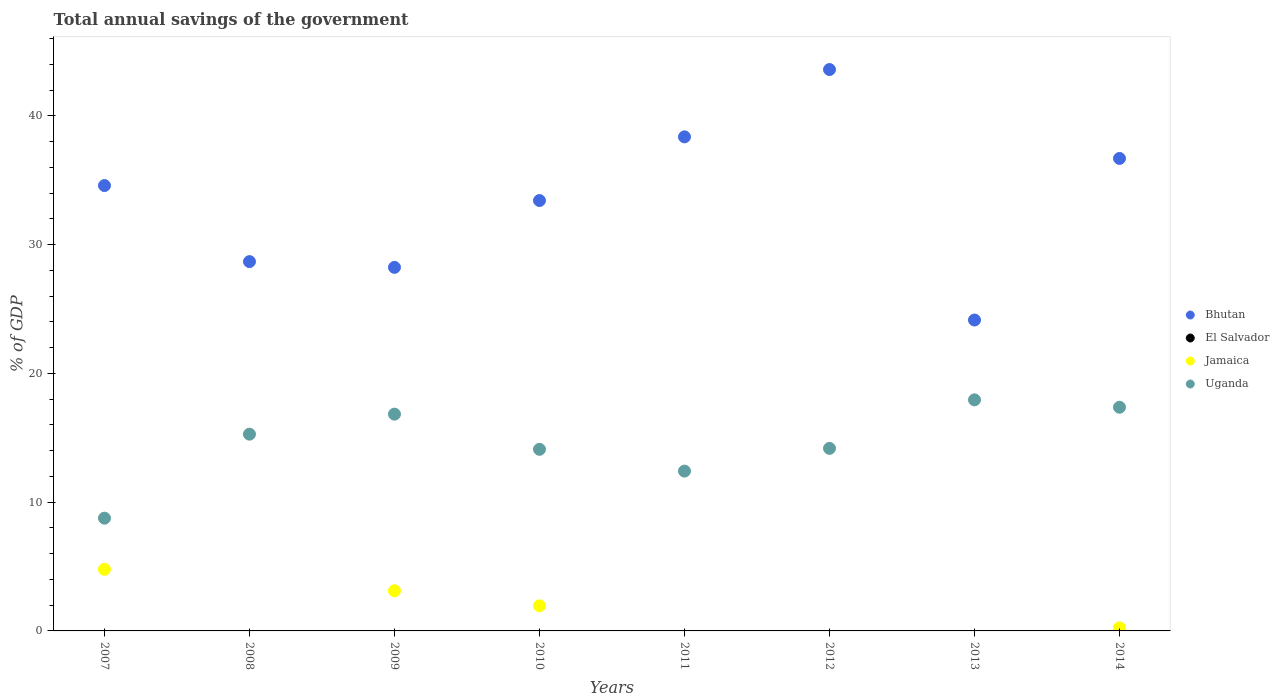How many different coloured dotlines are there?
Keep it short and to the point. 3. Is the number of dotlines equal to the number of legend labels?
Keep it short and to the point. No. What is the total annual savings of the government in Bhutan in 2013?
Provide a succinct answer. 24.15. Across all years, what is the maximum total annual savings of the government in Bhutan?
Offer a very short reply. 43.6. Across all years, what is the minimum total annual savings of the government in Uganda?
Give a very brief answer. 8.76. In which year was the total annual savings of the government in Jamaica maximum?
Provide a short and direct response. 2007. What is the total total annual savings of the government in Bhutan in the graph?
Your answer should be compact. 267.74. What is the difference between the total annual savings of the government in Jamaica in 2007 and that in 2010?
Your answer should be very brief. 2.84. What is the difference between the total annual savings of the government in Bhutan in 2012 and the total annual savings of the government in El Salvador in 2009?
Provide a succinct answer. 43.6. What is the average total annual savings of the government in El Salvador per year?
Provide a short and direct response. 0. In the year 2009, what is the difference between the total annual savings of the government in Bhutan and total annual savings of the government in Uganda?
Keep it short and to the point. 11.4. In how many years, is the total annual savings of the government in Bhutan greater than 34 %?
Your answer should be very brief. 4. What is the ratio of the total annual savings of the government in Uganda in 2009 to that in 2010?
Offer a terse response. 1.19. Is the total annual savings of the government in Bhutan in 2007 less than that in 2008?
Provide a short and direct response. No. What is the difference between the highest and the second highest total annual savings of the government in Uganda?
Provide a succinct answer. 0.58. What is the difference between the highest and the lowest total annual savings of the government in Bhutan?
Offer a terse response. 19.45. In how many years, is the total annual savings of the government in Uganda greater than the average total annual savings of the government in Uganda taken over all years?
Give a very brief answer. 4. Is the sum of the total annual savings of the government in Uganda in 2012 and 2013 greater than the maximum total annual savings of the government in Jamaica across all years?
Provide a succinct answer. Yes. Is it the case that in every year, the sum of the total annual savings of the government in Bhutan and total annual savings of the government in El Salvador  is greater than the sum of total annual savings of the government in Uganda and total annual savings of the government in Jamaica?
Make the answer very short. Yes. Does the total annual savings of the government in Jamaica monotonically increase over the years?
Give a very brief answer. No. Is the total annual savings of the government in Uganda strictly greater than the total annual savings of the government in Bhutan over the years?
Your answer should be very brief. No. Is the total annual savings of the government in Uganda strictly less than the total annual savings of the government in El Salvador over the years?
Keep it short and to the point. No. Are the values on the major ticks of Y-axis written in scientific E-notation?
Your answer should be very brief. No. Does the graph contain any zero values?
Your answer should be very brief. Yes. How many legend labels are there?
Keep it short and to the point. 4. How are the legend labels stacked?
Offer a very short reply. Vertical. What is the title of the graph?
Your response must be concise. Total annual savings of the government. What is the label or title of the Y-axis?
Give a very brief answer. % of GDP. What is the % of GDP in Bhutan in 2007?
Offer a very short reply. 34.59. What is the % of GDP of Jamaica in 2007?
Ensure brevity in your answer.  4.78. What is the % of GDP of Uganda in 2007?
Offer a terse response. 8.76. What is the % of GDP of Bhutan in 2008?
Make the answer very short. 28.68. What is the % of GDP in Jamaica in 2008?
Provide a short and direct response. 0. What is the % of GDP of Uganda in 2008?
Provide a short and direct response. 15.28. What is the % of GDP in Bhutan in 2009?
Make the answer very short. 28.23. What is the % of GDP in El Salvador in 2009?
Your answer should be compact. 0. What is the % of GDP of Jamaica in 2009?
Keep it short and to the point. 3.12. What is the % of GDP in Uganda in 2009?
Give a very brief answer. 16.84. What is the % of GDP in Bhutan in 2010?
Give a very brief answer. 33.42. What is the % of GDP of Jamaica in 2010?
Your answer should be compact. 1.95. What is the % of GDP in Uganda in 2010?
Your answer should be very brief. 14.1. What is the % of GDP in Bhutan in 2011?
Offer a very short reply. 38.37. What is the % of GDP of El Salvador in 2011?
Provide a succinct answer. 0. What is the % of GDP of Uganda in 2011?
Keep it short and to the point. 12.41. What is the % of GDP of Bhutan in 2012?
Offer a terse response. 43.6. What is the % of GDP in El Salvador in 2012?
Offer a terse response. 0. What is the % of GDP in Jamaica in 2012?
Make the answer very short. 0. What is the % of GDP in Uganda in 2012?
Give a very brief answer. 14.18. What is the % of GDP in Bhutan in 2013?
Offer a very short reply. 24.15. What is the % of GDP of El Salvador in 2013?
Provide a succinct answer. 0. What is the % of GDP of Jamaica in 2013?
Ensure brevity in your answer.  0. What is the % of GDP of Uganda in 2013?
Provide a succinct answer. 17.95. What is the % of GDP of Bhutan in 2014?
Offer a very short reply. 36.69. What is the % of GDP of El Salvador in 2014?
Your answer should be very brief. 0. What is the % of GDP of Jamaica in 2014?
Keep it short and to the point. 0.24. What is the % of GDP of Uganda in 2014?
Offer a very short reply. 17.37. Across all years, what is the maximum % of GDP of Bhutan?
Ensure brevity in your answer.  43.6. Across all years, what is the maximum % of GDP in Jamaica?
Ensure brevity in your answer.  4.78. Across all years, what is the maximum % of GDP of Uganda?
Your answer should be compact. 17.95. Across all years, what is the minimum % of GDP in Bhutan?
Your answer should be compact. 24.15. Across all years, what is the minimum % of GDP in Uganda?
Your answer should be compact. 8.76. What is the total % of GDP of Bhutan in the graph?
Provide a succinct answer. 267.74. What is the total % of GDP in El Salvador in the graph?
Ensure brevity in your answer.  0. What is the total % of GDP of Jamaica in the graph?
Keep it short and to the point. 10.09. What is the total % of GDP of Uganda in the graph?
Ensure brevity in your answer.  116.88. What is the difference between the % of GDP of Bhutan in 2007 and that in 2008?
Offer a terse response. 5.91. What is the difference between the % of GDP of Uganda in 2007 and that in 2008?
Give a very brief answer. -6.52. What is the difference between the % of GDP of Bhutan in 2007 and that in 2009?
Ensure brevity in your answer.  6.35. What is the difference between the % of GDP of Jamaica in 2007 and that in 2009?
Provide a succinct answer. 1.66. What is the difference between the % of GDP of Uganda in 2007 and that in 2009?
Your response must be concise. -8.08. What is the difference between the % of GDP of Bhutan in 2007 and that in 2010?
Keep it short and to the point. 1.16. What is the difference between the % of GDP of Jamaica in 2007 and that in 2010?
Your answer should be compact. 2.84. What is the difference between the % of GDP in Uganda in 2007 and that in 2010?
Offer a terse response. -5.35. What is the difference between the % of GDP of Bhutan in 2007 and that in 2011?
Offer a very short reply. -3.78. What is the difference between the % of GDP of Uganda in 2007 and that in 2011?
Keep it short and to the point. -3.66. What is the difference between the % of GDP of Bhutan in 2007 and that in 2012?
Provide a succinct answer. -9.01. What is the difference between the % of GDP in Uganda in 2007 and that in 2012?
Provide a short and direct response. -5.42. What is the difference between the % of GDP in Bhutan in 2007 and that in 2013?
Keep it short and to the point. 10.44. What is the difference between the % of GDP of Uganda in 2007 and that in 2013?
Offer a terse response. -9.19. What is the difference between the % of GDP in Bhutan in 2007 and that in 2014?
Your answer should be very brief. -2.11. What is the difference between the % of GDP of Jamaica in 2007 and that in 2014?
Make the answer very short. 4.55. What is the difference between the % of GDP in Uganda in 2007 and that in 2014?
Keep it short and to the point. -8.61. What is the difference between the % of GDP in Bhutan in 2008 and that in 2009?
Your answer should be compact. 0.45. What is the difference between the % of GDP in Uganda in 2008 and that in 2009?
Ensure brevity in your answer.  -1.56. What is the difference between the % of GDP of Bhutan in 2008 and that in 2010?
Make the answer very short. -4.74. What is the difference between the % of GDP in Uganda in 2008 and that in 2010?
Offer a terse response. 1.18. What is the difference between the % of GDP in Bhutan in 2008 and that in 2011?
Ensure brevity in your answer.  -9.69. What is the difference between the % of GDP of Uganda in 2008 and that in 2011?
Keep it short and to the point. 2.87. What is the difference between the % of GDP in Bhutan in 2008 and that in 2012?
Offer a terse response. -14.92. What is the difference between the % of GDP of Uganda in 2008 and that in 2012?
Your answer should be very brief. 1.1. What is the difference between the % of GDP in Bhutan in 2008 and that in 2013?
Give a very brief answer. 4.54. What is the difference between the % of GDP of Uganda in 2008 and that in 2013?
Ensure brevity in your answer.  -2.67. What is the difference between the % of GDP of Bhutan in 2008 and that in 2014?
Provide a succinct answer. -8.01. What is the difference between the % of GDP of Uganda in 2008 and that in 2014?
Your response must be concise. -2.09. What is the difference between the % of GDP of Bhutan in 2009 and that in 2010?
Offer a very short reply. -5.19. What is the difference between the % of GDP of Jamaica in 2009 and that in 2010?
Offer a very short reply. 1.17. What is the difference between the % of GDP in Uganda in 2009 and that in 2010?
Keep it short and to the point. 2.73. What is the difference between the % of GDP in Bhutan in 2009 and that in 2011?
Provide a succinct answer. -10.14. What is the difference between the % of GDP of Uganda in 2009 and that in 2011?
Offer a very short reply. 4.42. What is the difference between the % of GDP in Bhutan in 2009 and that in 2012?
Offer a terse response. -15.36. What is the difference between the % of GDP in Uganda in 2009 and that in 2012?
Your answer should be very brief. 2.66. What is the difference between the % of GDP in Bhutan in 2009 and that in 2013?
Your response must be concise. 4.09. What is the difference between the % of GDP of Uganda in 2009 and that in 2013?
Offer a terse response. -1.11. What is the difference between the % of GDP in Bhutan in 2009 and that in 2014?
Your answer should be compact. -8.46. What is the difference between the % of GDP of Jamaica in 2009 and that in 2014?
Provide a succinct answer. 2.88. What is the difference between the % of GDP in Uganda in 2009 and that in 2014?
Ensure brevity in your answer.  -0.53. What is the difference between the % of GDP in Bhutan in 2010 and that in 2011?
Provide a succinct answer. -4.95. What is the difference between the % of GDP of Uganda in 2010 and that in 2011?
Provide a succinct answer. 1.69. What is the difference between the % of GDP in Bhutan in 2010 and that in 2012?
Make the answer very short. -10.17. What is the difference between the % of GDP of Uganda in 2010 and that in 2012?
Provide a short and direct response. -0.07. What is the difference between the % of GDP in Bhutan in 2010 and that in 2013?
Your answer should be compact. 9.28. What is the difference between the % of GDP of Uganda in 2010 and that in 2013?
Provide a short and direct response. -3.84. What is the difference between the % of GDP of Bhutan in 2010 and that in 2014?
Offer a terse response. -3.27. What is the difference between the % of GDP of Jamaica in 2010 and that in 2014?
Keep it short and to the point. 1.71. What is the difference between the % of GDP in Uganda in 2010 and that in 2014?
Offer a terse response. -3.27. What is the difference between the % of GDP in Bhutan in 2011 and that in 2012?
Offer a terse response. -5.23. What is the difference between the % of GDP of Uganda in 2011 and that in 2012?
Offer a terse response. -1.76. What is the difference between the % of GDP of Bhutan in 2011 and that in 2013?
Give a very brief answer. 14.22. What is the difference between the % of GDP of Uganda in 2011 and that in 2013?
Your response must be concise. -5.53. What is the difference between the % of GDP in Bhutan in 2011 and that in 2014?
Ensure brevity in your answer.  1.68. What is the difference between the % of GDP of Uganda in 2011 and that in 2014?
Offer a very short reply. -4.96. What is the difference between the % of GDP of Bhutan in 2012 and that in 2013?
Provide a succinct answer. 19.45. What is the difference between the % of GDP in Uganda in 2012 and that in 2013?
Provide a short and direct response. -3.77. What is the difference between the % of GDP in Bhutan in 2012 and that in 2014?
Offer a very short reply. 6.9. What is the difference between the % of GDP in Uganda in 2012 and that in 2014?
Provide a succinct answer. -3.19. What is the difference between the % of GDP of Bhutan in 2013 and that in 2014?
Provide a short and direct response. -12.55. What is the difference between the % of GDP in Uganda in 2013 and that in 2014?
Give a very brief answer. 0.58. What is the difference between the % of GDP of Bhutan in 2007 and the % of GDP of Uganda in 2008?
Your response must be concise. 19.31. What is the difference between the % of GDP in Jamaica in 2007 and the % of GDP in Uganda in 2008?
Offer a terse response. -10.5. What is the difference between the % of GDP of Bhutan in 2007 and the % of GDP of Jamaica in 2009?
Ensure brevity in your answer.  31.47. What is the difference between the % of GDP of Bhutan in 2007 and the % of GDP of Uganda in 2009?
Keep it short and to the point. 17.75. What is the difference between the % of GDP in Jamaica in 2007 and the % of GDP in Uganda in 2009?
Your answer should be compact. -12.05. What is the difference between the % of GDP in Bhutan in 2007 and the % of GDP in Jamaica in 2010?
Keep it short and to the point. 32.64. What is the difference between the % of GDP in Bhutan in 2007 and the % of GDP in Uganda in 2010?
Give a very brief answer. 20.49. What is the difference between the % of GDP of Jamaica in 2007 and the % of GDP of Uganda in 2010?
Ensure brevity in your answer.  -9.32. What is the difference between the % of GDP in Bhutan in 2007 and the % of GDP in Uganda in 2011?
Your answer should be compact. 22.18. What is the difference between the % of GDP of Jamaica in 2007 and the % of GDP of Uganda in 2011?
Offer a terse response. -7.63. What is the difference between the % of GDP in Bhutan in 2007 and the % of GDP in Uganda in 2012?
Offer a terse response. 20.41. What is the difference between the % of GDP of Jamaica in 2007 and the % of GDP of Uganda in 2012?
Your answer should be compact. -9.39. What is the difference between the % of GDP of Bhutan in 2007 and the % of GDP of Uganda in 2013?
Keep it short and to the point. 16.64. What is the difference between the % of GDP in Jamaica in 2007 and the % of GDP in Uganda in 2013?
Your answer should be very brief. -13.16. What is the difference between the % of GDP of Bhutan in 2007 and the % of GDP of Jamaica in 2014?
Your answer should be very brief. 34.35. What is the difference between the % of GDP in Bhutan in 2007 and the % of GDP in Uganda in 2014?
Give a very brief answer. 17.22. What is the difference between the % of GDP of Jamaica in 2007 and the % of GDP of Uganda in 2014?
Provide a succinct answer. -12.59. What is the difference between the % of GDP of Bhutan in 2008 and the % of GDP of Jamaica in 2009?
Offer a very short reply. 25.56. What is the difference between the % of GDP of Bhutan in 2008 and the % of GDP of Uganda in 2009?
Ensure brevity in your answer.  11.85. What is the difference between the % of GDP of Bhutan in 2008 and the % of GDP of Jamaica in 2010?
Your response must be concise. 26.73. What is the difference between the % of GDP in Bhutan in 2008 and the % of GDP in Uganda in 2010?
Give a very brief answer. 14.58. What is the difference between the % of GDP of Bhutan in 2008 and the % of GDP of Uganda in 2011?
Your response must be concise. 16.27. What is the difference between the % of GDP of Bhutan in 2008 and the % of GDP of Uganda in 2012?
Provide a short and direct response. 14.5. What is the difference between the % of GDP of Bhutan in 2008 and the % of GDP of Uganda in 2013?
Keep it short and to the point. 10.74. What is the difference between the % of GDP in Bhutan in 2008 and the % of GDP in Jamaica in 2014?
Keep it short and to the point. 28.44. What is the difference between the % of GDP of Bhutan in 2008 and the % of GDP of Uganda in 2014?
Offer a terse response. 11.31. What is the difference between the % of GDP in Bhutan in 2009 and the % of GDP in Jamaica in 2010?
Give a very brief answer. 26.29. What is the difference between the % of GDP of Bhutan in 2009 and the % of GDP of Uganda in 2010?
Give a very brief answer. 14.13. What is the difference between the % of GDP of Jamaica in 2009 and the % of GDP of Uganda in 2010?
Your response must be concise. -10.98. What is the difference between the % of GDP in Bhutan in 2009 and the % of GDP in Uganda in 2011?
Your response must be concise. 15.82. What is the difference between the % of GDP of Jamaica in 2009 and the % of GDP of Uganda in 2011?
Your answer should be very brief. -9.29. What is the difference between the % of GDP in Bhutan in 2009 and the % of GDP in Uganda in 2012?
Give a very brief answer. 14.06. What is the difference between the % of GDP in Jamaica in 2009 and the % of GDP in Uganda in 2012?
Your answer should be very brief. -11.06. What is the difference between the % of GDP of Bhutan in 2009 and the % of GDP of Uganda in 2013?
Provide a succinct answer. 10.29. What is the difference between the % of GDP in Jamaica in 2009 and the % of GDP in Uganda in 2013?
Your answer should be very brief. -14.83. What is the difference between the % of GDP in Bhutan in 2009 and the % of GDP in Jamaica in 2014?
Your answer should be very brief. 28. What is the difference between the % of GDP of Bhutan in 2009 and the % of GDP of Uganda in 2014?
Ensure brevity in your answer.  10.86. What is the difference between the % of GDP of Jamaica in 2009 and the % of GDP of Uganda in 2014?
Give a very brief answer. -14.25. What is the difference between the % of GDP of Bhutan in 2010 and the % of GDP of Uganda in 2011?
Your answer should be compact. 21.01. What is the difference between the % of GDP in Jamaica in 2010 and the % of GDP in Uganda in 2011?
Your answer should be very brief. -10.46. What is the difference between the % of GDP of Bhutan in 2010 and the % of GDP of Uganda in 2012?
Keep it short and to the point. 19.25. What is the difference between the % of GDP in Jamaica in 2010 and the % of GDP in Uganda in 2012?
Your response must be concise. -12.23. What is the difference between the % of GDP of Bhutan in 2010 and the % of GDP of Uganda in 2013?
Provide a short and direct response. 15.48. What is the difference between the % of GDP of Jamaica in 2010 and the % of GDP of Uganda in 2013?
Ensure brevity in your answer.  -16. What is the difference between the % of GDP in Bhutan in 2010 and the % of GDP in Jamaica in 2014?
Ensure brevity in your answer.  33.18. What is the difference between the % of GDP of Bhutan in 2010 and the % of GDP of Uganda in 2014?
Your answer should be very brief. 16.05. What is the difference between the % of GDP in Jamaica in 2010 and the % of GDP in Uganda in 2014?
Your answer should be very brief. -15.42. What is the difference between the % of GDP of Bhutan in 2011 and the % of GDP of Uganda in 2012?
Ensure brevity in your answer.  24.19. What is the difference between the % of GDP of Bhutan in 2011 and the % of GDP of Uganda in 2013?
Offer a very short reply. 20.42. What is the difference between the % of GDP of Bhutan in 2011 and the % of GDP of Jamaica in 2014?
Your answer should be very brief. 38.13. What is the difference between the % of GDP in Bhutan in 2011 and the % of GDP in Uganda in 2014?
Provide a short and direct response. 21. What is the difference between the % of GDP of Bhutan in 2012 and the % of GDP of Uganda in 2013?
Keep it short and to the point. 25.65. What is the difference between the % of GDP of Bhutan in 2012 and the % of GDP of Jamaica in 2014?
Your response must be concise. 43.36. What is the difference between the % of GDP in Bhutan in 2012 and the % of GDP in Uganda in 2014?
Your answer should be compact. 26.23. What is the difference between the % of GDP in Bhutan in 2013 and the % of GDP in Jamaica in 2014?
Provide a succinct answer. 23.91. What is the difference between the % of GDP of Bhutan in 2013 and the % of GDP of Uganda in 2014?
Provide a short and direct response. 6.78. What is the average % of GDP in Bhutan per year?
Offer a terse response. 33.47. What is the average % of GDP in El Salvador per year?
Your answer should be compact. 0. What is the average % of GDP of Jamaica per year?
Provide a succinct answer. 1.26. What is the average % of GDP of Uganda per year?
Offer a terse response. 14.61. In the year 2007, what is the difference between the % of GDP of Bhutan and % of GDP of Jamaica?
Make the answer very short. 29.8. In the year 2007, what is the difference between the % of GDP of Bhutan and % of GDP of Uganda?
Ensure brevity in your answer.  25.83. In the year 2007, what is the difference between the % of GDP in Jamaica and % of GDP in Uganda?
Offer a terse response. -3.97. In the year 2008, what is the difference between the % of GDP of Bhutan and % of GDP of Uganda?
Ensure brevity in your answer.  13.4. In the year 2009, what is the difference between the % of GDP of Bhutan and % of GDP of Jamaica?
Provide a short and direct response. 25.12. In the year 2009, what is the difference between the % of GDP in Bhutan and % of GDP in Uganda?
Your response must be concise. 11.4. In the year 2009, what is the difference between the % of GDP in Jamaica and % of GDP in Uganda?
Provide a short and direct response. -13.72. In the year 2010, what is the difference between the % of GDP in Bhutan and % of GDP in Jamaica?
Offer a very short reply. 31.48. In the year 2010, what is the difference between the % of GDP in Bhutan and % of GDP in Uganda?
Offer a very short reply. 19.32. In the year 2010, what is the difference between the % of GDP of Jamaica and % of GDP of Uganda?
Your answer should be compact. -12.15. In the year 2011, what is the difference between the % of GDP of Bhutan and % of GDP of Uganda?
Give a very brief answer. 25.96. In the year 2012, what is the difference between the % of GDP in Bhutan and % of GDP in Uganda?
Make the answer very short. 29.42. In the year 2013, what is the difference between the % of GDP in Bhutan and % of GDP in Uganda?
Your response must be concise. 6.2. In the year 2014, what is the difference between the % of GDP in Bhutan and % of GDP in Jamaica?
Offer a terse response. 36.45. In the year 2014, what is the difference between the % of GDP of Bhutan and % of GDP of Uganda?
Your response must be concise. 19.32. In the year 2014, what is the difference between the % of GDP in Jamaica and % of GDP in Uganda?
Make the answer very short. -17.13. What is the ratio of the % of GDP in Bhutan in 2007 to that in 2008?
Your response must be concise. 1.21. What is the ratio of the % of GDP in Uganda in 2007 to that in 2008?
Your answer should be compact. 0.57. What is the ratio of the % of GDP of Bhutan in 2007 to that in 2009?
Give a very brief answer. 1.23. What is the ratio of the % of GDP in Jamaica in 2007 to that in 2009?
Ensure brevity in your answer.  1.53. What is the ratio of the % of GDP in Uganda in 2007 to that in 2009?
Your answer should be compact. 0.52. What is the ratio of the % of GDP in Bhutan in 2007 to that in 2010?
Make the answer very short. 1.03. What is the ratio of the % of GDP of Jamaica in 2007 to that in 2010?
Offer a terse response. 2.46. What is the ratio of the % of GDP in Uganda in 2007 to that in 2010?
Offer a very short reply. 0.62. What is the ratio of the % of GDP in Bhutan in 2007 to that in 2011?
Offer a terse response. 0.9. What is the ratio of the % of GDP of Uganda in 2007 to that in 2011?
Give a very brief answer. 0.71. What is the ratio of the % of GDP in Bhutan in 2007 to that in 2012?
Offer a very short reply. 0.79. What is the ratio of the % of GDP of Uganda in 2007 to that in 2012?
Your response must be concise. 0.62. What is the ratio of the % of GDP of Bhutan in 2007 to that in 2013?
Provide a short and direct response. 1.43. What is the ratio of the % of GDP in Uganda in 2007 to that in 2013?
Provide a short and direct response. 0.49. What is the ratio of the % of GDP of Bhutan in 2007 to that in 2014?
Offer a terse response. 0.94. What is the ratio of the % of GDP of Jamaica in 2007 to that in 2014?
Your response must be concise. 20.02. What is the ratio of the % of GDP of Uganda in 2007 to that in 2014?
Offer a terse response. 0.5. What is the ratio of the % of GDP of Bhutan in 2008 to that in 2009?
Keep it short and to the point. 1.02. What is the ratio of the % of GDP in Uganda in 2008 to that in 2009?
Give a very brief answer. 0.91. What is the ratio of the % of GDP of Bhutan in 2008 to that in 2010?
Give a very brief answer. 0.86. What is the ratio of the % of GDP in Uganda in 2008 to that in 2010?
Provide a succinct answer. 1.08. What is the ratio of the % of GDP in Bhutan in 2008 to that in 2011?
Your response must be concise. 0.75. What is the ratio of the % of GDP of Uganda in 2008 to that in 2011?
Offer a terse response. 1.23. What is the ratio of the % of GDP of Bhutan in 2008 to that in 2012?
Keep it short and to the point. 0.66. What is the ratio of the % of GDP of Uganda in 2008 to that in 2012?
Offer a terse response. 1.08. What is the ratio of the % of GDP in Bhutan in 2008 to that in 2013?
Provide a succinct answer. 1.19. What is the ratio of the % of GDP of Uganda in 2008 to that in 2013?
Make the answer very short. 0.85. What is the ratio of the % of GDP of Bhutan in 2008 to that in 2014?
Your answer should be very brief. 0.78. What is the ratio of the % of GDP in Uganda in 2008 to that in 2014?
Provide a succinct answer. 0.88. What is the ratio of the % of GDP of Bhutan in 2009 to that in 2010?
Your response must be concise. 0.84. What is the ratio of the % of GDP of Jamaica in 2009 to that in 2010?
Give a very brief answer. 1.6. What is the ratio of the % of GDP in Uganda in 2009 to that in 2010?
Your response must be concise. 1.19. What is the ratio of the % of GDP of Bhutan in 2009 to that in 2011?
Keep it short and to the point. 0.74. What is the ratio of the % of GDP of Uganda in 2009 to that in 2011?
Offer a terse response. 1.36. What is the ratio of the % of GDP of Bhutan in 2009 to that in 2012?
Provide a succinct answer. 0.65. What is the ratio of the % of GDP of Uganda in 2009 to that in 2012?
Give a very brief answer. 1.19. What is the ratio of the % of GDP in Bhutan in 2009 to that in 2013?
Your answer should be compact. 1.17. What is the ratio of the % of GDP of Uganda in 2009 to that in 2013?
Provide a short and direct response. 0.94. What is the ratio of the % of GDP of Bhutan in 2009 to that in 2014?
Provide a succinct answer. 0.77. What is the ratio of the % of GDP in Jamaica in 2009 to that in 2014?
Ensure brevity in your answer.  13.05. What is the ratio of the % of GDP in Uganda in 2009 to that in 2014?
Your response must be concise. 0.97. What is the ratio of the % of GDP in Bhutan in 2010 to that in 2011?
Your answer should be compact. 0.87. What is the ratio of the % of GDP of Uganda in 2010 to that in 2011?
Provide a succinct answer. 1.14. What is the ratio of the % of GDP of Bhutan in 2010 to that in 2012?
Keep it short and to the point. 0.77. What is the ratio of the % of GDP of Uganda in 2010 to that in 2012?
Offer a very short reply. 0.99. What is the ratio of the % of GDP in Bhutan in 2010 to that in 2013?
Offer a terse response. 1.38. What is the ratio of the % of GDP of Uganda in 2010 to that in 2013?
Offer a terse response. 0.79. What is the ratio of the % of GDP in Bhutan in 2010 to that in 2014?
Your answer should be compact. 0.91. What is the ratio of the % of GDP of Jamaica in 2010 to that in 2014?
Offer a terse response. 8.15. What is the ratio of the % of GDP in Uganda in 2010 to that in 2014?
Your answer should be compact. 0.81. What is the ratio of the % of GDP of Bhutan in 2011 to that in 2012?
Provide a succinct answer. 0.88. What is the ratio of the % of GDP of Uganda in 2011 to that in 2012?
Provide a succinct answer. 0.88. What is the ratio of the % of GDP of Bhutan in 2011 to that in 2013?
Your answer should be compact. 1.59. What is the ratio of the % of GDP in Uganda in 2011 to that in 2013?
Offer a very short reply. 0.69. What is the ratio of the % of GDP in Bhutan in 2011 to that in 2014?
Ensure brevity in your answer.  1.05. What is the ratio of the % of GDP of Uganda in 2011 to that in 2014?
Your answer should be compact. 0.71. What is the ratio of the % of GDP of Bhutan in 2012 to that in 2013?
Give a very brief answer. 1.81. What is the ratio of the % of GDP of Uganda in 2012 to that in 2013?
Provide a short and direct response. 0.79. What is the ratio of the % of GDP in Bhutan in 2012 to that in 2014?
Your answer should be compact. 1.19. What is the ratio of the % of GDP in Uganda in 2012 to that in 2014?
Provide a succinct answer. 0.82. What is the ratio of the % of GDP of Bhutan in 2013 to that in 2014?
Ensure brevity in your answer.  0.66. What is the ratio of the % of GDP in Uganda in 2013 to that in 2014?
Make the answer very short. 1.03. What is the difference between the highest and the second highest % of GDP in Bhutan?
Provide a succinct answer. 5.23. What is the difference between the highest and the second highest % of GDP in Jamaica?
Your answer should be very brief. 1.66. What is the difference between the highest and the second highest % of GDP in Uganda?
Offer a terse response. 0.58. What is the difference between the highest and the lowest % of GDP in Bhutan?
Your response must be concise. 19.45. What is the difference between the highest and the lowest % of GDP in Jamaica?
Provide a succinct answer. 4.78. What is the difference between the highest and the lowest % of GDP of Uganda?
Your response must be concise. 9.19. 